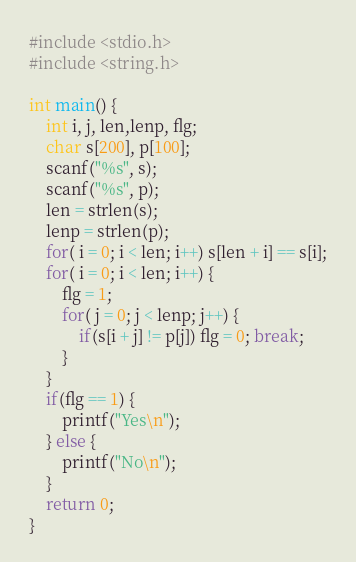Convert code to text. <code><loc_0><loc_0><loc_500><loc_500><_C_>#include <stdio.h>
#include <string.h>

int main() {
	int i, j, len,lenp, flg;
	char s[200], p[100];
	scanf("%s", s);
	scanf("%s", p);
	len = strlen(s);
	lenp = strlen(p);
	for( i = 0; i < len; i++) s[len + i] == s[i];
	for( i = 0; i < len; i++) {
		flg = 1;
		for( j = 0; j < lenp; j++) {
			if(s[i + j] != p[j]) flg = 0; break;
		}
	}
	if(flg == 1) {
		printf("Yes\n");
	} else {
		printf("No\n");
	}
	return 0;
}</code> 